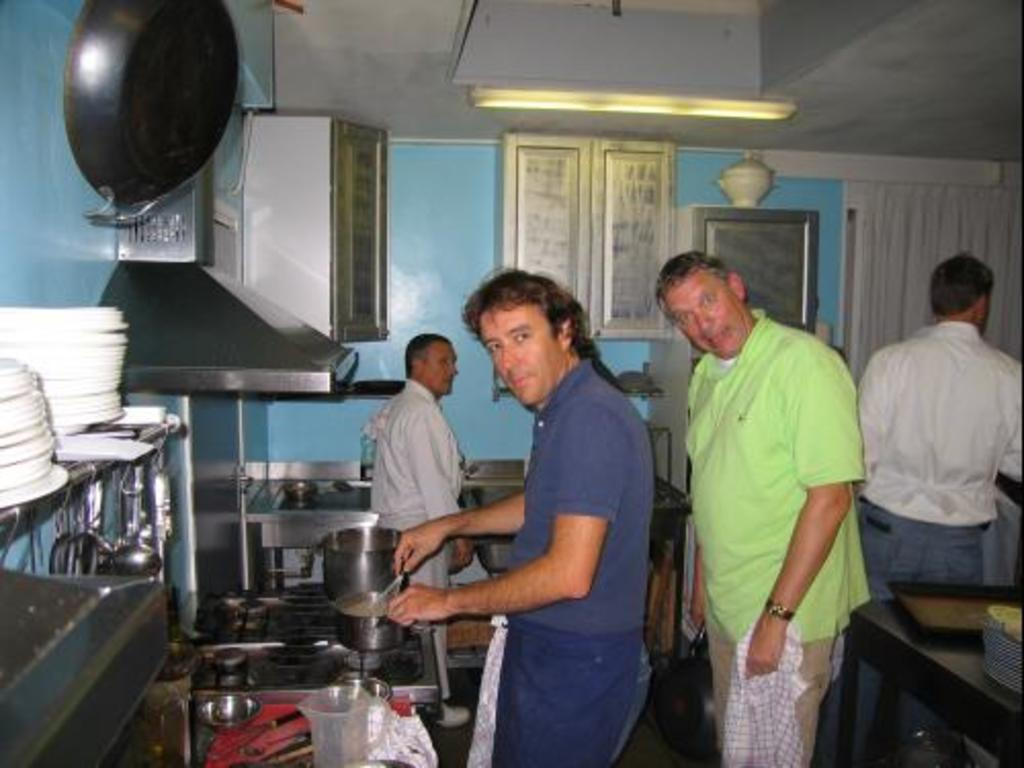How many people can be seen in the image? There are people in the image, but the exact number is not specified. What type of cooking appliance is present in the image? There is a stove in the image. What type of dishware is present in the image? There are bowls, plates, and spoons in the image. What type of container is present in the image? There is a jug in the image. What type of storage furniture is present in the image? There are closets in the image. What type of surface is present in the image? There is a table in the image. What type of carrying surface is present in the image? There is a tray in the image. What type of vertical structure is present in the image? There is a chimney in the image. What type of barrier is present in the image? There is a wall in the image. What type of covering is present in the image? There is a roof in the image. Can you tell me how many dogs are sitting on the stove in the image? There are no dogs present in the image, and the stove is not mentioned as a location for any animals. What type of impulse can be seen affecting the chimney in the image? There is no mention of any impulses affecting the chimney or any other objects in the image. 